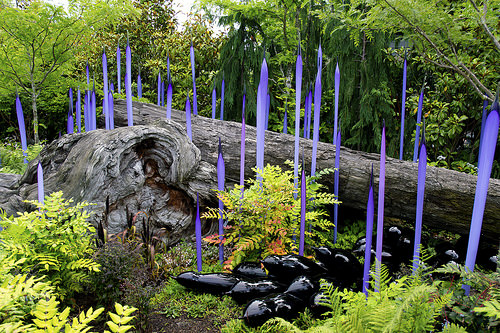<image>
Is the log behind the branch? No. The log is not behind the branch. From this viewpoint, the log appears to be positioned elsewhere in the scene. 